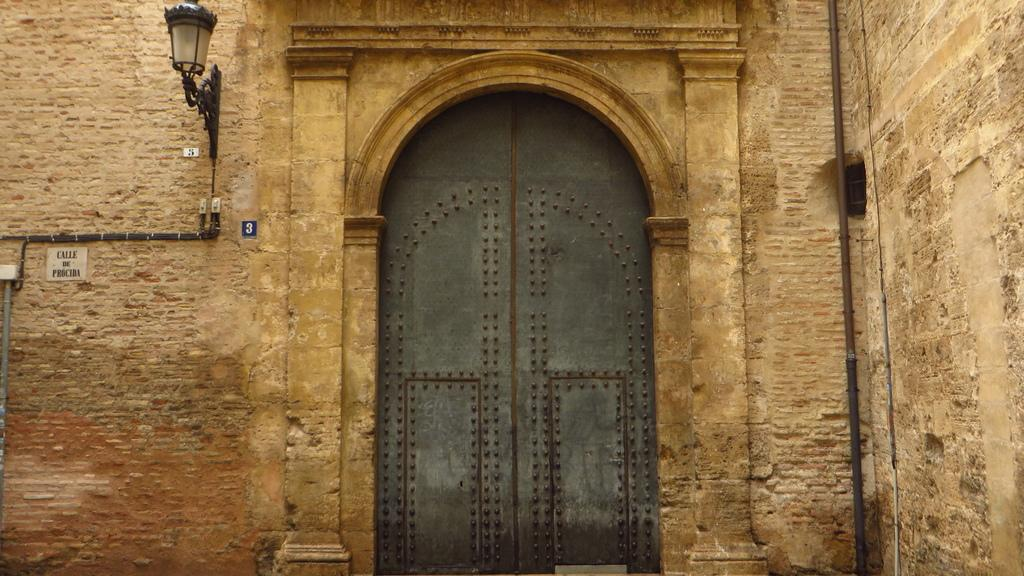What type of structure is visible in the image? There is a building in the image. Can you describe any specific features of the building? The building has a door in the middle. What is visible at the top of the building? There is light at the top of the building. What time of day is it in the image, considering the presence of morning light? The provided facts do not mention any specific time of day or morning light, so it cannot be determined from the image. 